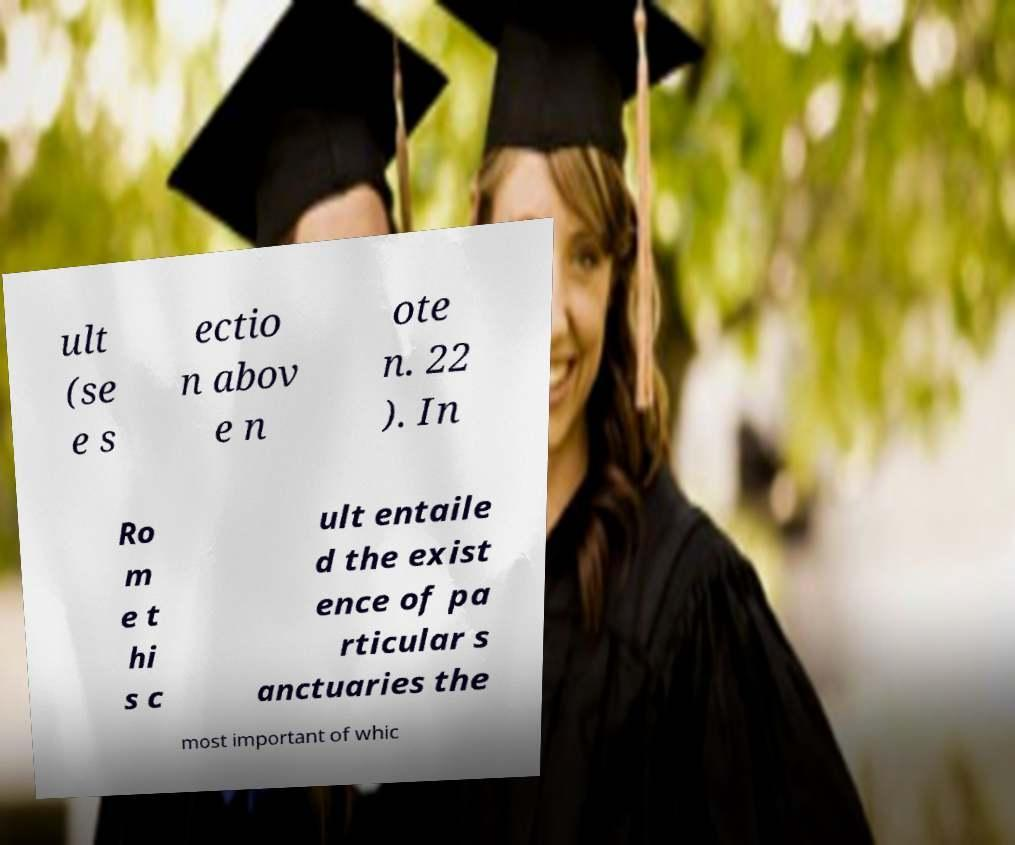For documentation purposes, I need the text within this image transcribed. Could you provide that? ult (se e s ectio n abov e n ote n. 22 ). In Ro m e t hi s c ult entaile d the exist ence of pa rticular s anctuaries the most important of whic 